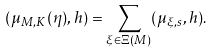<formula> <loc_0><loc_0><loc_500><loc_500>( \mu _ { M , K } ( \eta ) , h ) = \sum _ { \xi \in \Xi ( M ) } ( \mu _ { \xi , s } , h ) .</formula> 